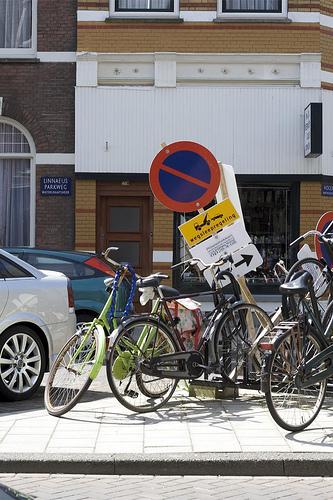How many different types of vehicles are here?
Quick response, please. 2. Is this in the city?
Keep it brief. Yes. Would you car be towed if it was parked to the right?
Answer briefly. Yes. 